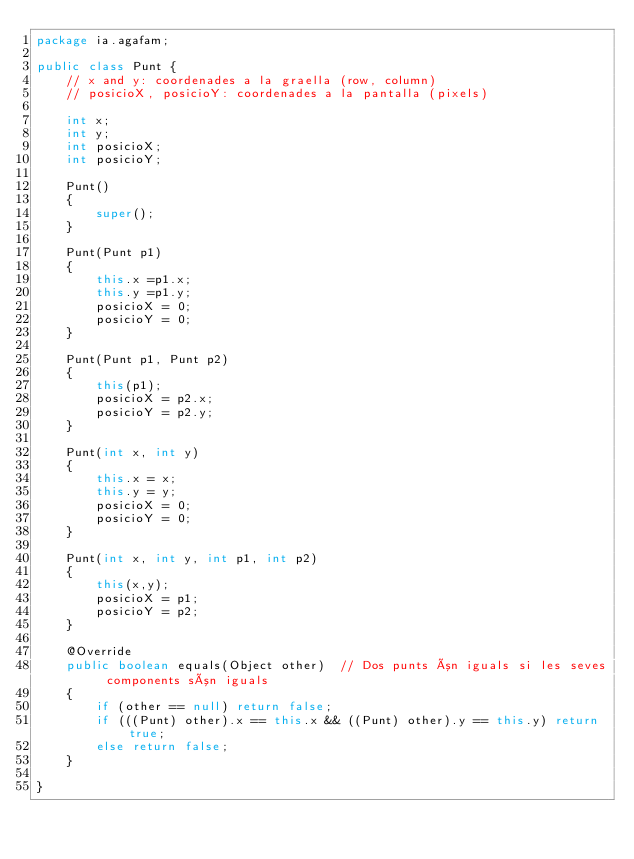Convert code to text. <code><loc_0><loc_0><loc_500><loc_500><_Java_>package ia.agafam;

public class Punt {
	// x and y: coordenades a la graella (row, column)
	// posicioX, posicioY: coordenades a la pantalla (pixels)
	
	int x;
	int y;
	int posicioX;
	int posicioY;
	
	Punt()
	{
		super();
	}
	
	Punt(Punt p1)
	{
		this.x =p1.x;
		this.y =p1.y;
		posicioX = 0;
		posicioY = 0;
	}
	
	Punt(Punt p1, Punt p2)
	{
		this(p1);
		posicioX = p2.x;
		posicioY = p2.y;
	}
	
	Punt(int x, int y)
	{
		this.x = x;
		this.y = y;
		posicioX = 0;
		posicioY = 0;
	}
	
	Punt(int x, int y, int p1, int p2)
	{
		this(x,y);
		posicioX = p1;
		posicioY = p2;
	}
	
    @Override
    public boolean equals(Object other)  // Dos punts ón iguals si les seves components són iguals
    {
        if (other == null) return false;
        if (((Punt) other).x == this.x && ((Punt) other).y == this.y) return true;
        else return false;
    } 
	
}
</code> 